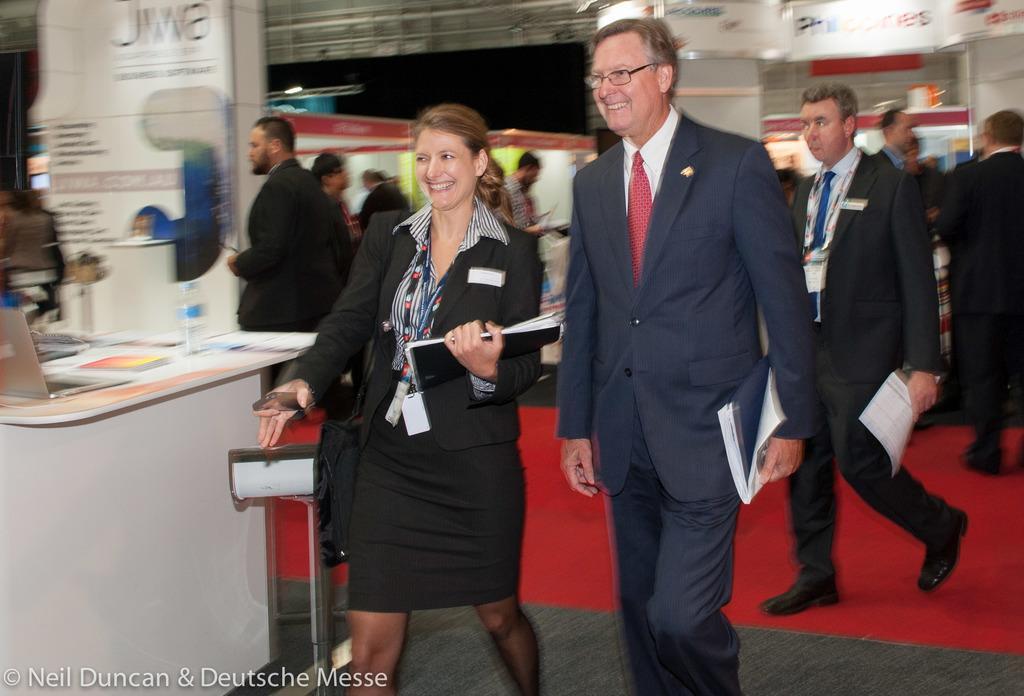Please provide a concise description of this image. In the foreground of the image there is a person wearing a suit. Beside him there is a lady holding papers in her hands. In the background of the image there are people. There are stalls. There are banners with some text. To the left side of the image there is a table with a laptop, books, water bottle. At the bottom of the image there is some text and carpet. 